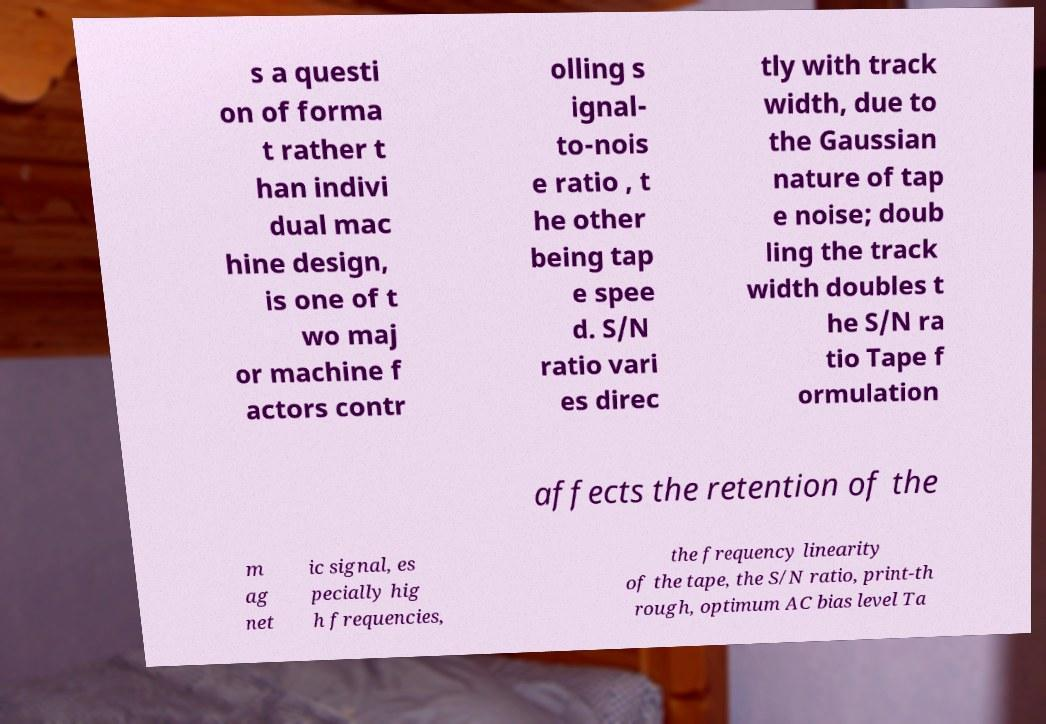Could you extract and type out the text from this image? s a questi on of forma t rather t han indivi dual mac hine design, is one of t wo maj or machine f actors contr olling s ignal- to-nois e ratio , t he other being tap e spee d. S/N ratio vari es direc tly with track width, due to the Gaussian nature of tap e noise; doub ling the track width doubles t he S/N ra tio Tape f ormulation affects the retention of the m ag net ic signal, es pecially hig h frequencies, the frequency linearity of the tape, the S/N ratio, print-th rough, optimum AC bias level Ta 